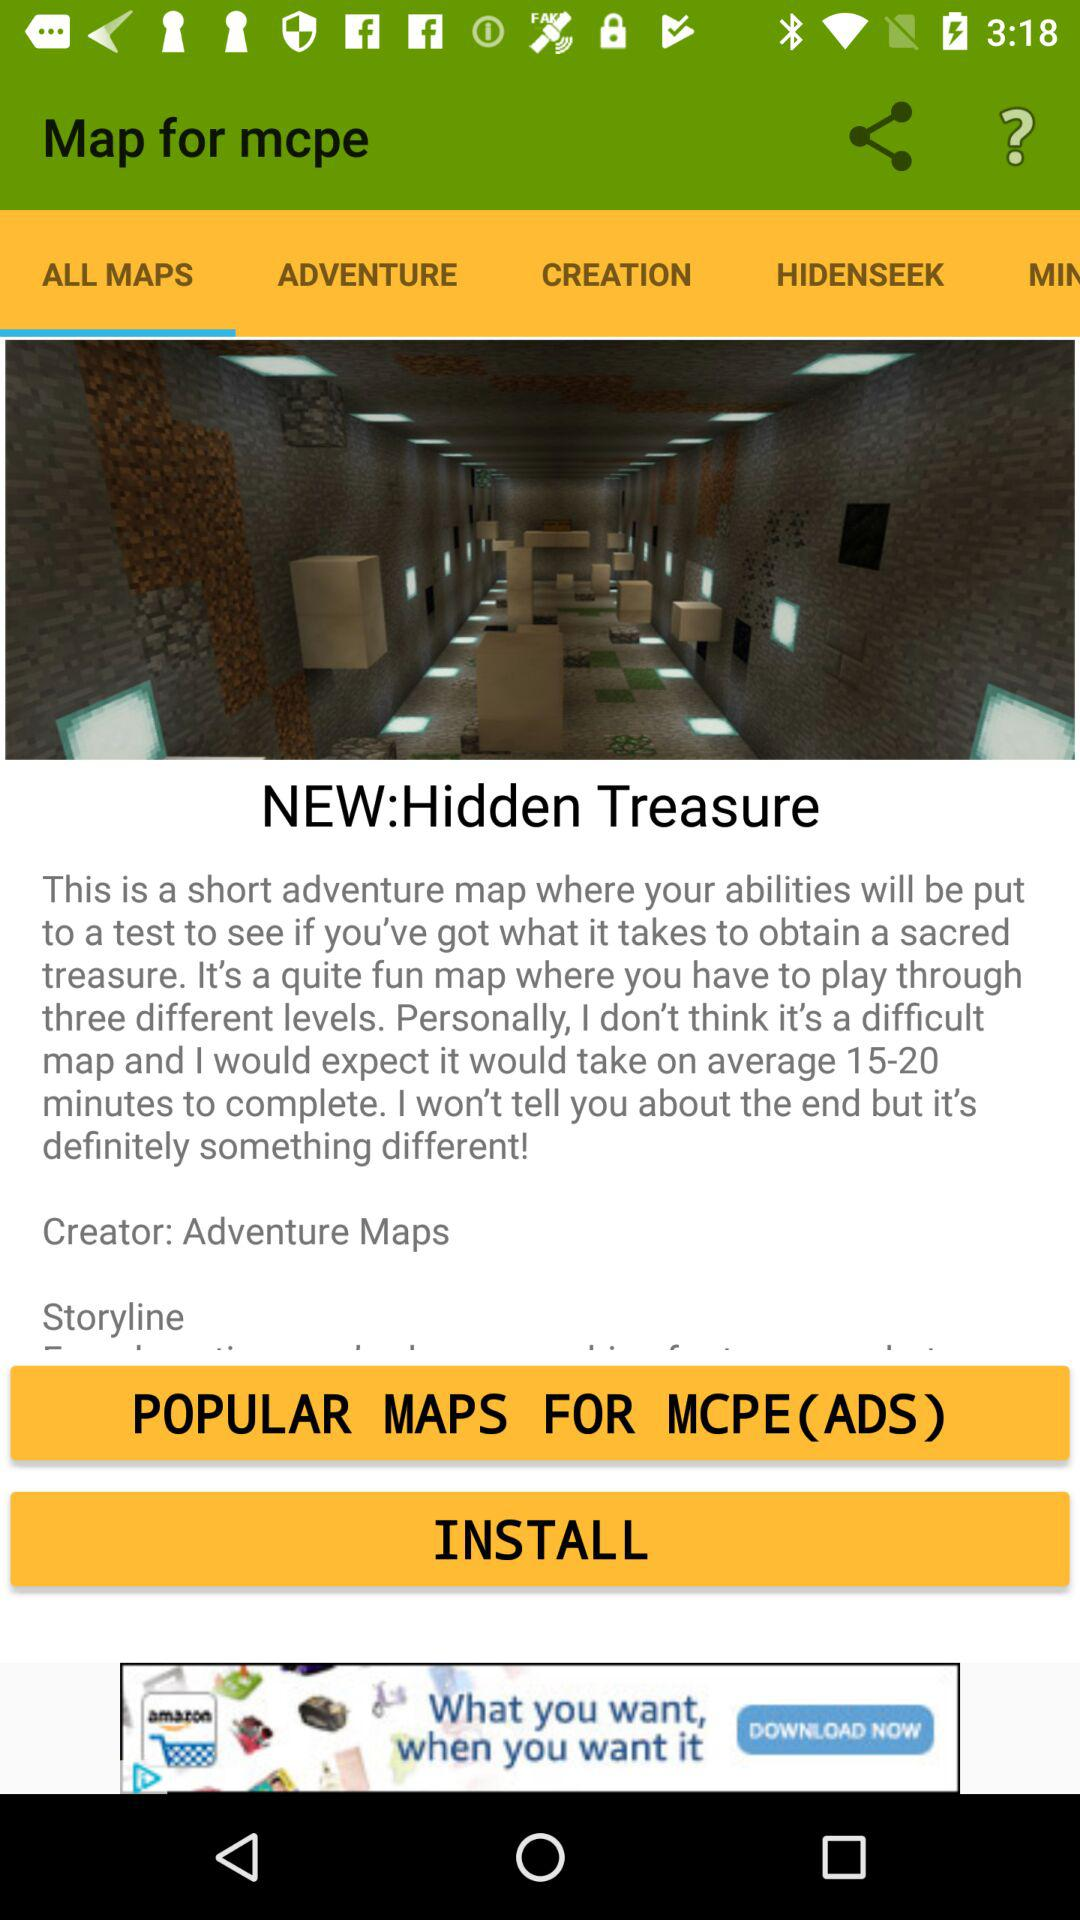How much time will "NEW:Hidden Treasure" take to complete? "NEW:Hidden Treasure" will take on average 15 to 20 minutes to complete. 